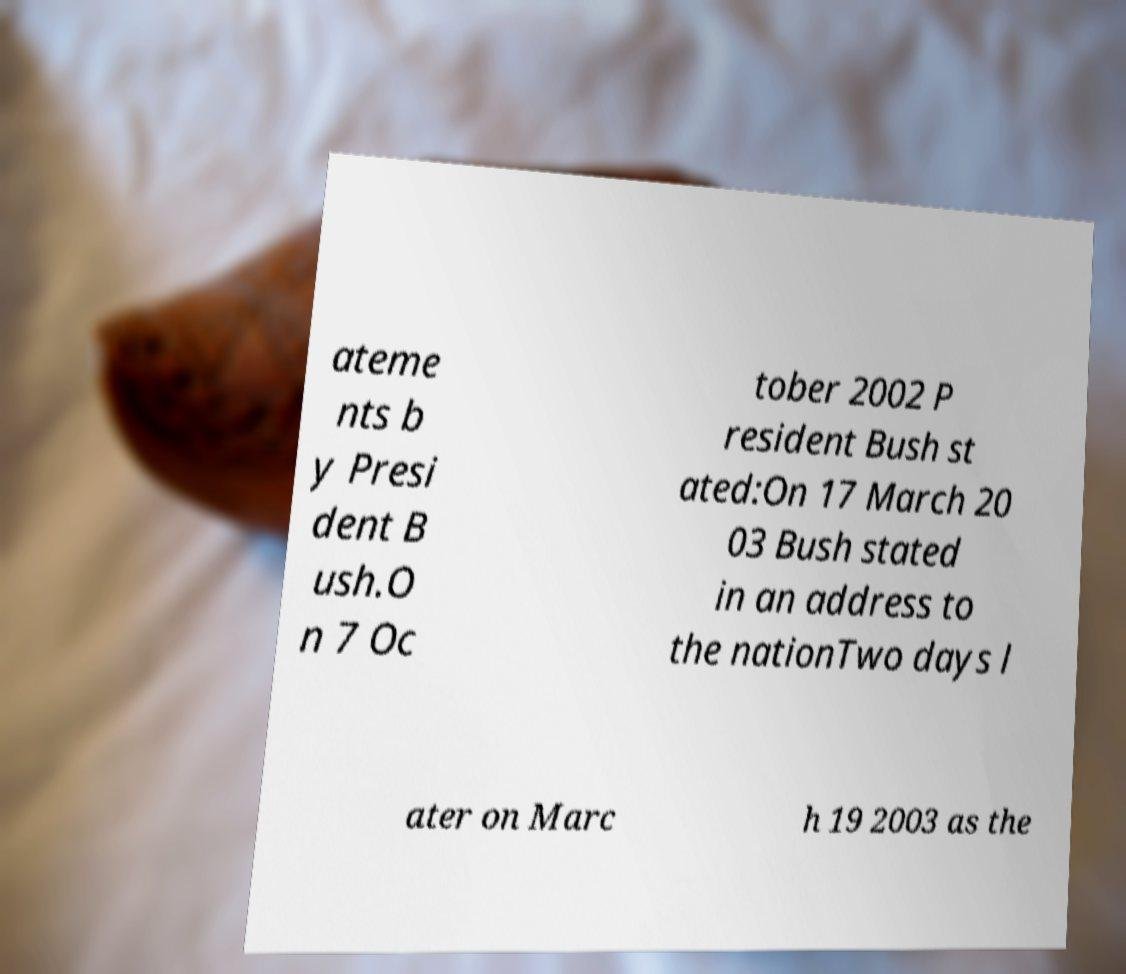What messages or text are displayed in this image? I need them in a readable, typed format. ateme nts b y Presi dent B ush.O n 7 Oc tober 2002 P resident Bush st ated:On 17 March 20 03 Bush stated in an address to the nationTwo days l ater on Marc h 19 2003 as the 